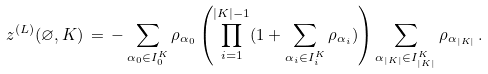<formula> <loc_0><loc_0><loc_500><loc_500>z ^ { ( L ) } ( \varnothing , K ) \, = \, - \sum _ { \alpha _ { 0 } \in I _ { 0 } ^ { K } } \rho _ { \alpha _ { 0 } } \left ( \prod _ { i = 1 } ^ { | K | - 1 } ( 1 + \sum _ { \alpha _ { i } \in I _ { i } ^ { K } } \rho _ { \alpha _ { i } } ) \right ) \sum _ { \alpha _ { | K | } \in I _ { | K | } ^ { K } } \rho _ { \alpha _ { | K | } } \, .</formula> 